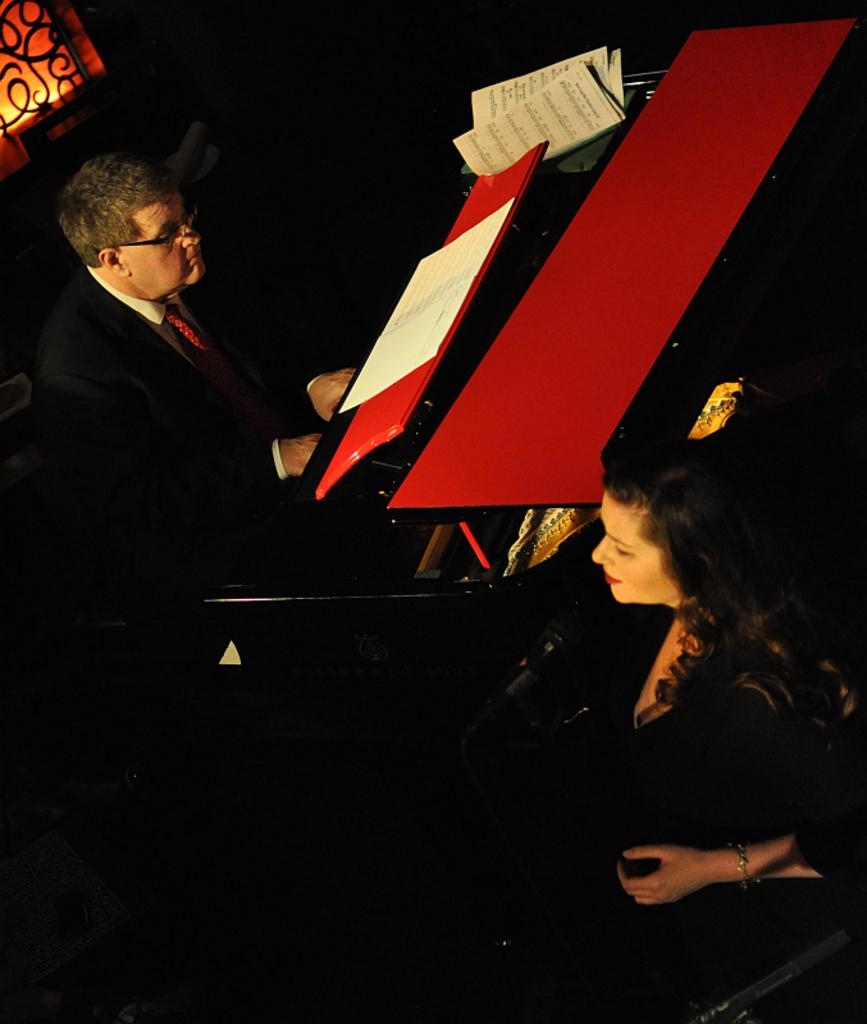What is the man in the image doing? The man is playing a musical instrument in the image. What can be seen on the man's face in the image? The man is wearing spectacles in the image. What object is present near the man in the image? There is a book in the image. What is the woman in the image doing? The woman is in front of a microphone in the image. What type of reaction can be seen on the man's face when the woman starts to play with the cat in the image? There is no cat present in the image, so it is not possible to determine any reactions related to a cat. 